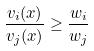<formula> <loc_0><loc_0><loc_500><loc_500>\frac { v _ { i } ( x ) } { v _ { j } ( x ) } \geq \frac { w _ { i } } { w _ { j } }</formula> 